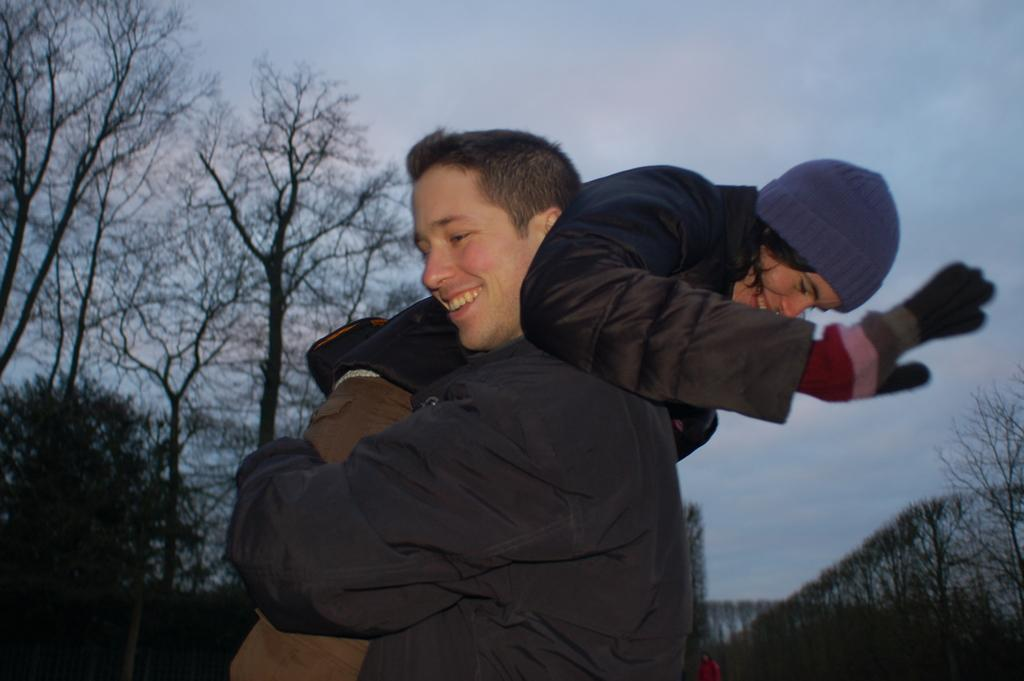What is happening between the two people in the image? There is a person holding another person in the image. What can be seen on the head of the person being held? The person being held is wearing a cap. What type of clothing is the person being held wearing on their hands? The person being held is wearing gloves. What can be seen in the distance behind the two people? There are trees in the background of the image. What is visible above the trees in the image? The sky is visible in the background of the image. What type of belief does the rat in the image have? There is no rat present in the image, so it is not possible to determine any beliefs it might have. 